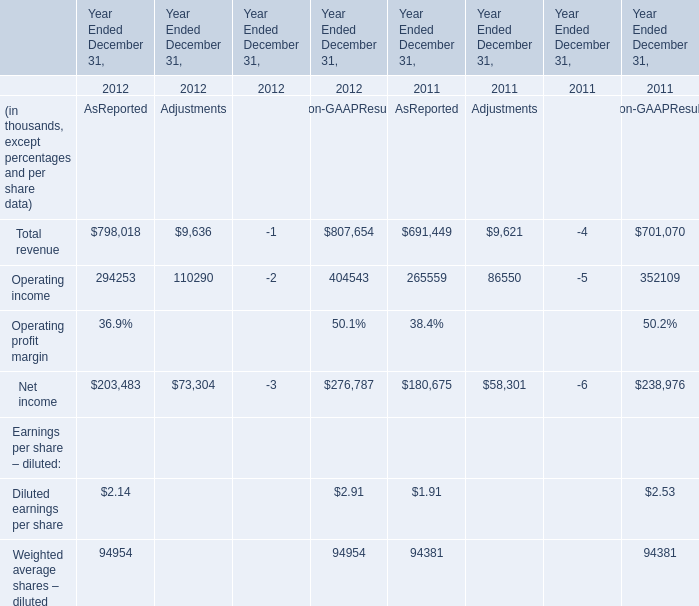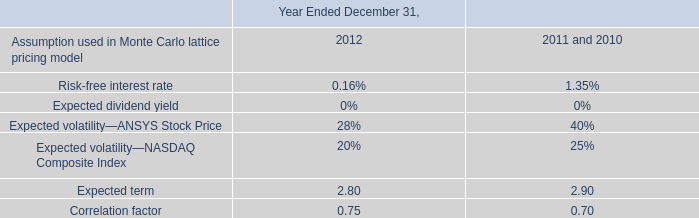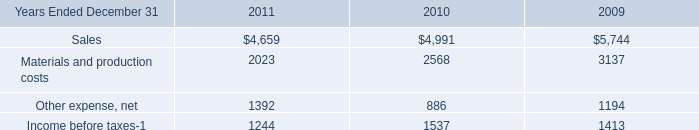what was the average total compensation expense associated with the awards granted for the years ending december 31 , 2013 and 2014? 
Computations: ((2.2 + 1.2) / 2)
Answer: 1.7. 